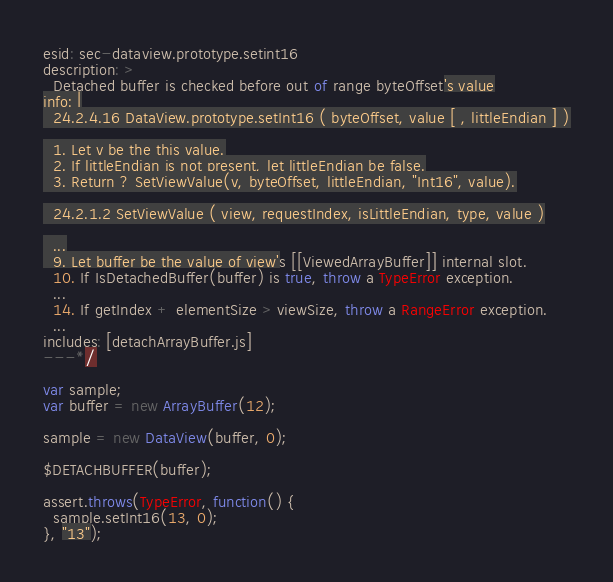<code> <loc_0><loc_0><loc_500><loc_500><_JavaScript_>esid: sec-dataview.prototype.setint16
description: >
  Detached buffer is checked before out of range byteOffset's value
info: |
  24.2.4.16 DataView.prototype.setInt16 ( byteOffset, value [ , littleEndian ] )

  1. Let v be the this value.
  2. If littleEndian is not present, let littleEndian be false.
  3. Return ? SetViewValue(v, byteOffset, littleEndian, "Int16", value).

  24.2.1.2 SetViewValue ( view, requestIndex, isLittleEndian, type, value )

  ...
  9. Let buffer be the value of view's [[ViewedArrayBuffer]] internal slot.
  10. If IsDetachedBuffer(buffer) is true, throw a TypeError exception.
  ...
  14. If getIndex + elementSize > viewSize, throw a RangeError exception.
  ...
includes: [detachArrayBuffer.js]
---*/

var sample;
var buffer = new ArrayBuffer(12);

sample = new DataView(buffer, 0);

$DETACHBUFFER(buffer);

assert.throws(TypeError, function() {
  sample.setInt16(13, 0);
}, "13");
</code> 